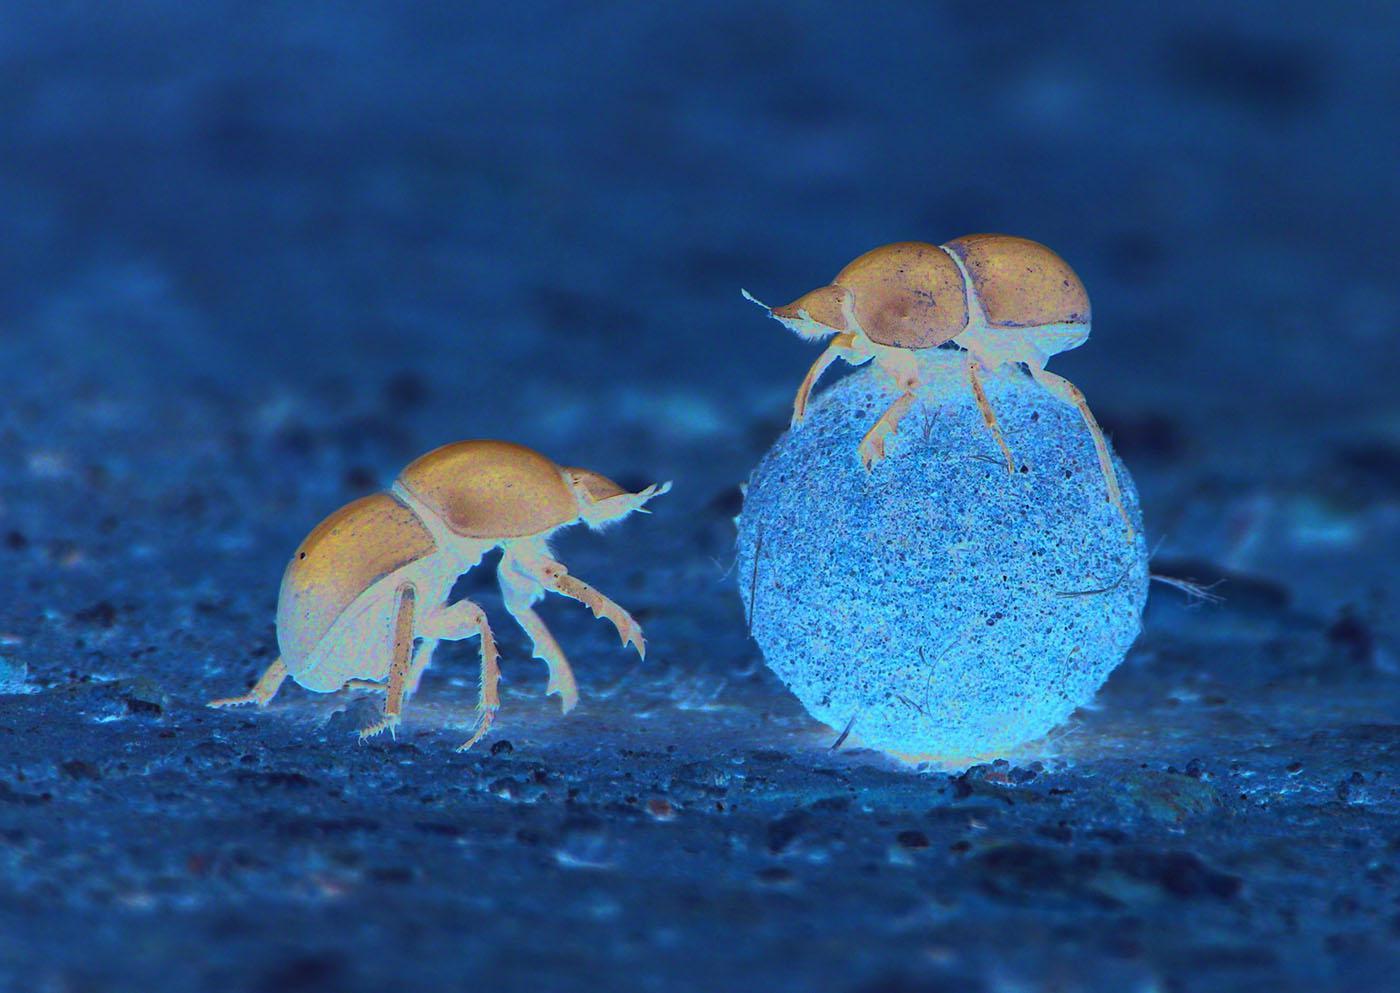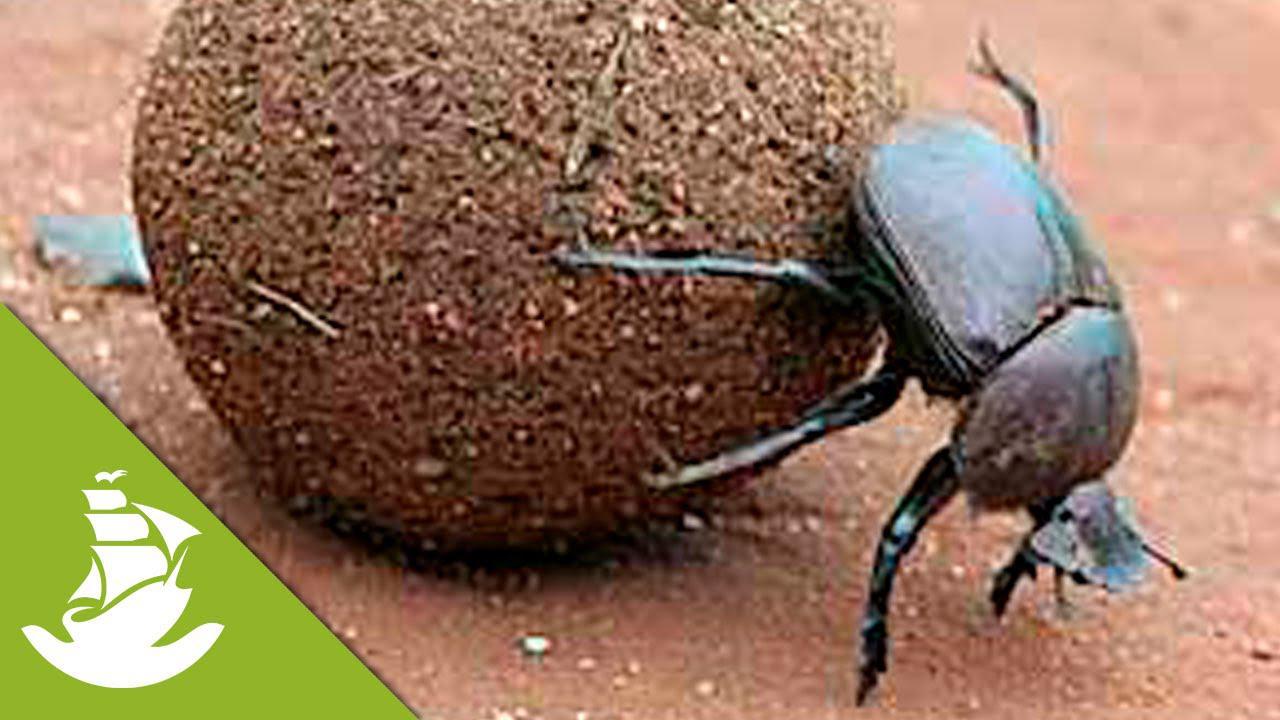The first image is the image on the left, the second image is the image on the right. For the images displayed, is the sentence "There are exactly two insects in one of the images." factually correct? Answer yes or no. Yes. 